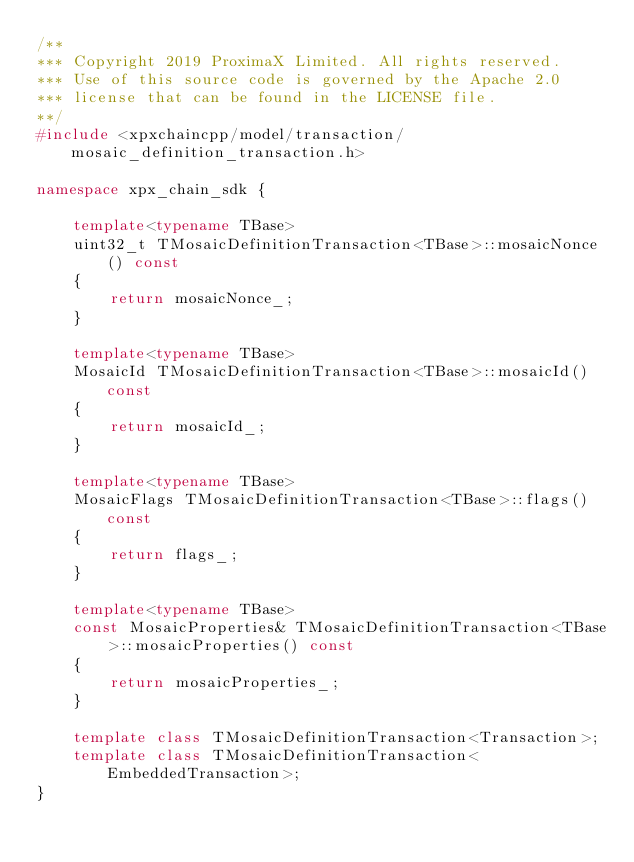<code> <loc_0><loc_0><loc_500><loc_500><_C++_>/**
*** Copyright 2019 ProximaX Limited. All rights reserved.
*** Use of this source code is governed by the Apache 2.0
*** license that can be found in the LICENSE file.
**/
#include <xpxchaincpp/model/transaction/mosaic_definition_transaction.h>

namespace xpx_chain_sdk {
	
	template<typename TBase>
	uint32_t TMosaicDefinitionTransaction<TBase>::mosaicNonce() const
	{
		return mosaicNonce_;
	}
	
	template<typename TBase>
	MosaicId TMosaicDefinitionTransaction<TBase>::mosaicId() const
	{
		return mosaicId_;
	}

	template<typename TBase>
	MosaicFlags TMosaicDefinitionTransaction<TBase>::flags() const
	{
		return flags_;
	}
	
	template<typename TBase>
	const MosaicProperties& TMosaicDefinitionTransaction<TBase>::mosaicProperties() const
	{
		return mosaicProperties_;
	}
	
	template class TMosaicDefinitionTransaction<Transaction>;
	template class TMosaicDefinitionTransaction<EmbeddedTransaction>;
}
</code> 